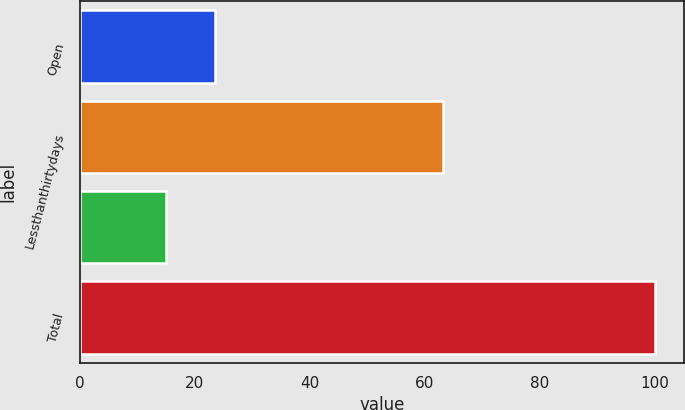<chart> <loc_0><loc_0><loc_500><loc_500><bar_chart><fcel>Open<fcel>Lessthanthirtydays<fcel>Unnamed: 2<fcel>Total<nl><fcel>23.41<fcel>63.1<fcel>14.9<fcel>100<nl></chart> 